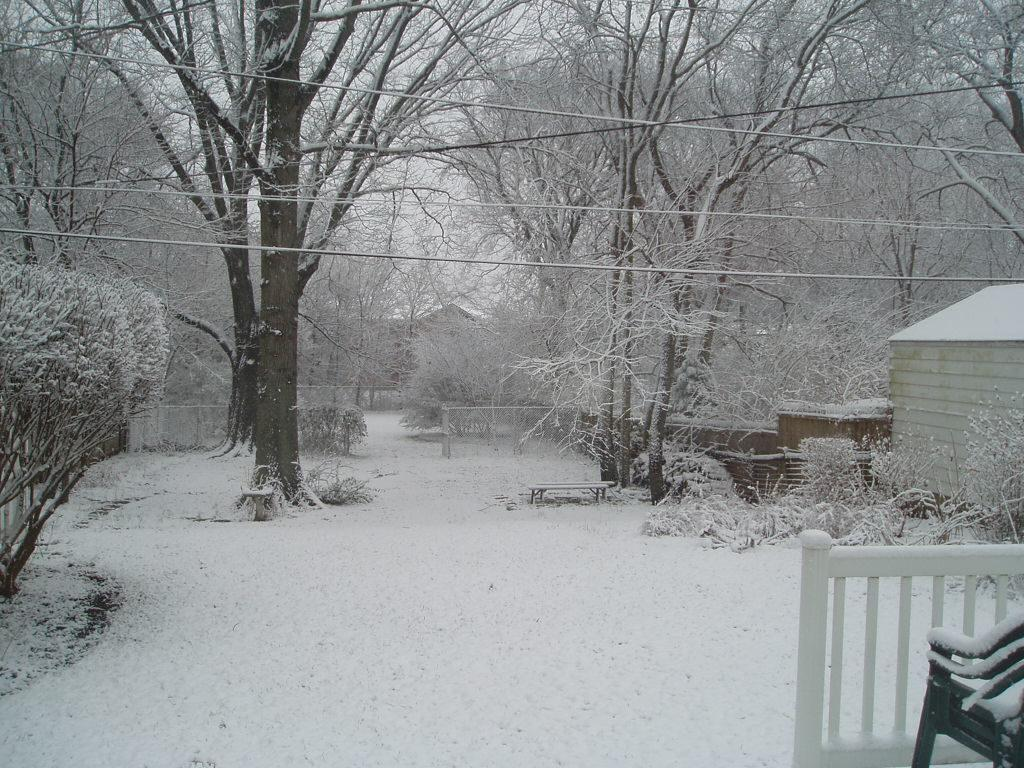What type of vegetation can be seen in the image? There are trees in the image. What is the weather like in the image? There is snow visible in the image, indicating a cold or wintery environment. What type of structures are present in the image? There are houses in the image. What is the railing used for in the image? The railing is likely used for support or safety, as it is often found on stairs or balconies. What type of furniture is present in the image? There are chairs in the image. Can you describe any other objects in the image? There are other objects in the image, but their specific details are not mentioned in the provided facts. What type of appliance is plugged into the cable in the image? There is no cable or appliance mentioned in the provided facts, so we cannot answer this question based on the image. 